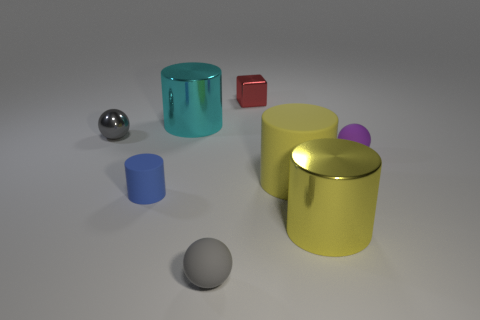Is there any other thing that has the same color as the tiny rubber cylinder?
Ensure brevity in your answer.  No. There is a large shiny thing that is the same color as the large matte cylinder; what shape is it?
Offer a very short reply. Cylinder. There is a rubber cylinder that is the same size as the gray rubber thing; what is its color?
Provide a succinct answer. Blue. How many shiny things are there?
Give a very brief answer. 4. Does the tiny ball right of the small red shiny thing have the same material as the blue cylinder?
Give a very brief answer. Yes. There is a object that is both behind the small rubber cylinder and right of the large rubber object; what material is it made of?
Offer a very short reply. Rubber. The shiny cylinder that is the same color as the large matte object is what size?
Make the answer very short. Large. The small gray ball on the left side of the metal cylinder behind the purple matte ball is made of what material?
Give a very brief answer. Metal. What is the size of the yellow cylinder that is behind the metallic cylinder on the right side of the small gray object in front of the tiny metal sphere?
Your response must be concise. Large. How many big cylinders are made of the same material as the purple thing?
Provide a short and direct response. 1. 